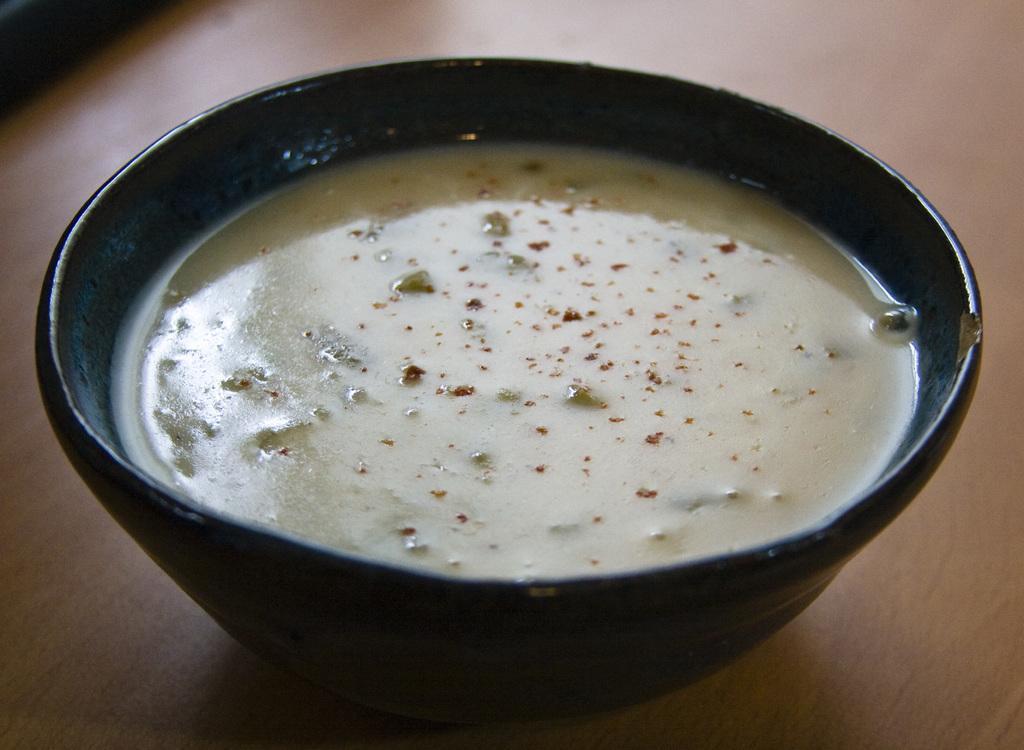Please provide a concise description of this image. In this picture we can see food in a bowl and this bowl is on the platform. 